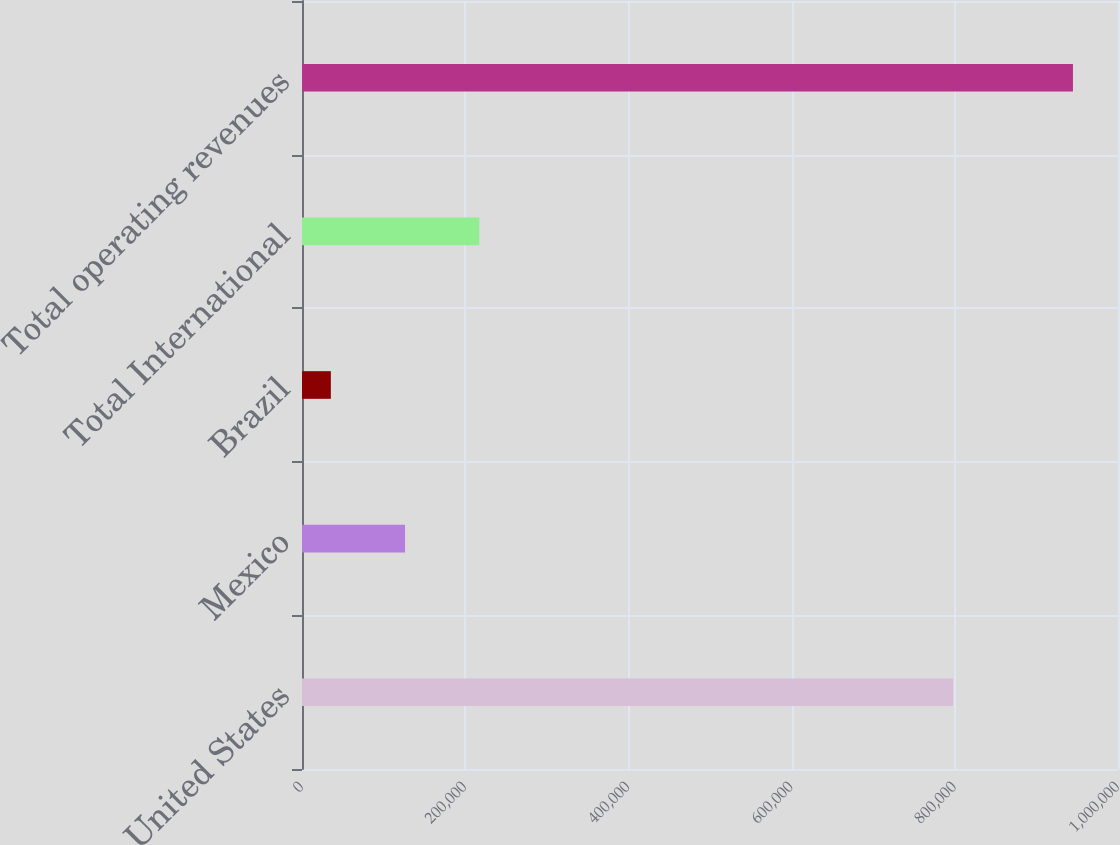<chart> <loc_0><loc_0><loc_500><loc_500><bar_chart><fcel>United States<fcel>Mexico<fcel>Brazil<fcel>Total International<fcel>Total operating revenues<nl><fcel>798010<fcel>126298<fcel>35355<fcel>217241<fcel>944786<nl></chart> 